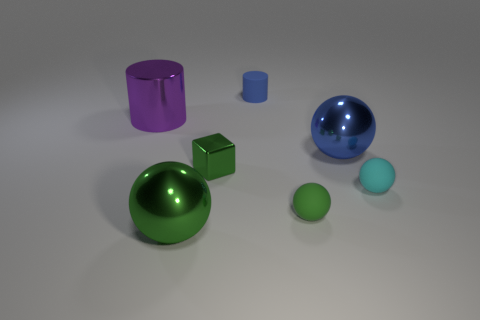How many small green things are behind the green rubber sphere in front of the blue thing that is in front of the large purple metal cylinder?
Your answer should be compact. 1. The cylinder that is the same size as the blue metallic sphere is what color?
Offer a very short reply. Purple. What is the size of the green metal object right of the large ball that is on the left side of the big blue metal sphere?
Provide a short and direct response. Small. There is a metallic ball that is the same color as the tiny cylinder; what size is it?
Offer a very short reply. Large. What number of other objects are the same size as the purple metallic object?
Provide a succinct answer. 2. What number of purple shiny cylinders are there?
Provide a short and direct response. 1. Does the green cube have the same size as the purple metallic cylinder?
Give a very brief answer. No. What number of other things are the same shape as the cyan matte object?
Offer a terse response. 3. There is a large object in front of the tiny cyan matte ball in front of the small green block; what is it made of?
Make the answer very short. Metal. Are there any big green balls right of the blue rubber cylinder?
Your answer should be compact. No. 